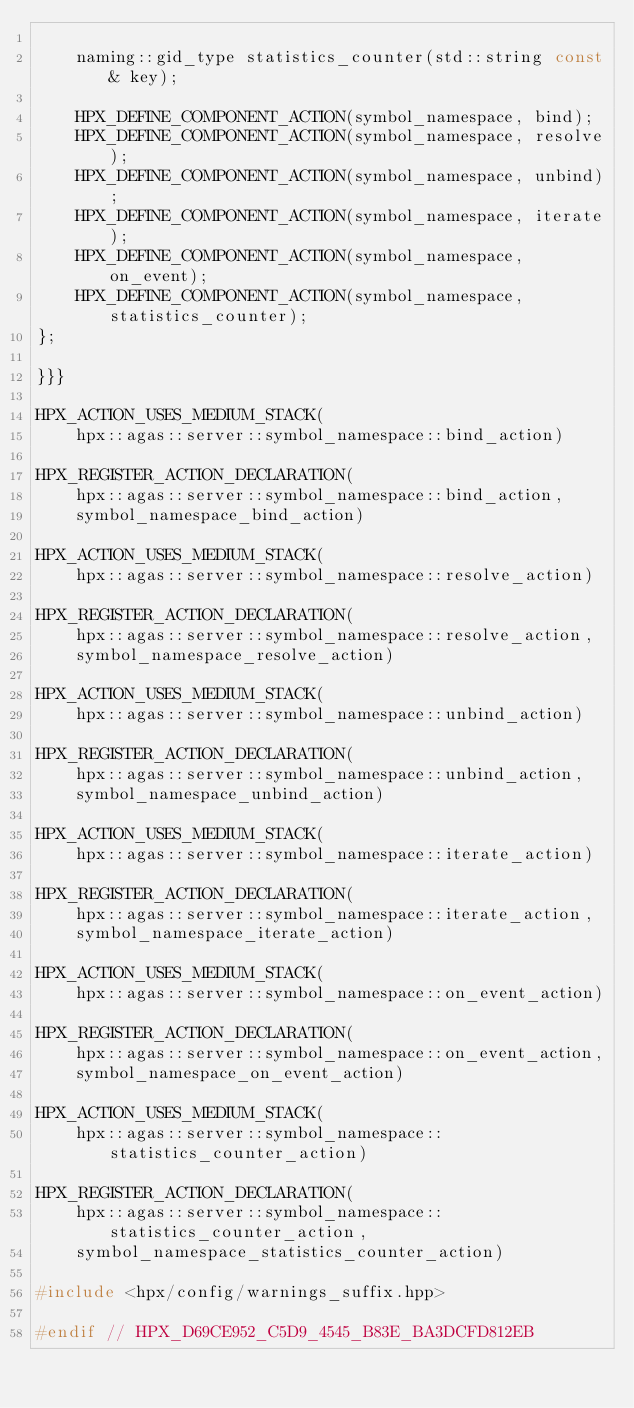<code> <loc_0><loc_0><loc_500><loc_500><_C++_>
    naming::gid_type statistics_counter(std::string const& key);

    HPX_DEFINE_COMPONENT_ACTION(symbol_namespace, bind);
    HPX_DEFINE_COMPONENT_ACTION(symbol_namespace, resolve);
    HPX_DEFINE_COMPONENT_ACTION(symbol_namespace, unbind);
    HPX_DEFINE_COMPONENT_ACTION(symbol_namespace, iterate);
    HPX_DEFINE_COMPONENT_ACTION(symbol_namespace, on_event);
    HPX_DEFINE_COMPONENT_ACTION(symbol_namespace, statistics_counter);
};

}}}

HPX_ACTION_USES_MEDIUM_STACK(
    hpx::agas::server::symbol_namespace::bind_action)

HPX_REGISTER_ACTION_DECLARATION(
    hpx::agas::server::symbol_namespace::bind_action,
    symbol_namespace_bind_action)

HPX_ACTION_USES_MEDIUM_STACK(
    hpx::agas::server::symbol_namespace::resolve_action)

HPX_REGISTER_ACTION_DECLARATION(
    hpx::agas::server::symbol_namespace::resolve_action,
    symbol_namespace_resolve_action)

HPX_ACTION_USES_MEDIUM_STACK(
    hpx::agas::server::symbol_namespace::unbind_action)

HPX_REGISTER_ACTION_DECLARATION(
    hpx::agas::server::symbol_namespace::unbind_action,
    symbol_namespace_unbind_action)

HPX_ACTION_USES_MEDIUM_STACK(
    hpx::agas::server::symbol_namespace::iterate_action)

HPX_REGISTER_ACTION_DECLARATION(
    hpx::agas::server::symbol_namespace::iterate_action,
    symbol_namespace_iterate_action)

HPX_ACTION_USES_MEDIUM_STACK(
    hpx::agas::server::symbol_namespace::on_event_action)

HPX_REGISTER_ACTION_DECLARATION(
    hpx::agas::server::symbol_namespace::on_event_action,
    symbol_namespace_on_event_action)

HPX_ACTION_USES_MEDIUM_STACK(
    hpx::agas::server::symbol_namespace::statistics_counter_action)

HPX_REGISTER_ACTION_DECLARATION(
    hpx::agas::server::symbol_namespace::statistics_counter_action,
    symbol_namespace_statistics_counter_action)

#include <hpx/config/warnings_suffix.hpp>

#endif // HPX_D69CE952_C5D9_4545_B83E_BA3DCFD812EB

</code> 